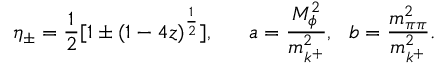Convert formula to latex. <formula><loc_0><loc_0><loc_500><loc_500>\eta _ { \pm } = { \frac { 1 } { 2 } } [ 1 \pm ( 1 - 4 z ) ^ { \frac { 1 } { 2 } } ] , a = { \frac { M _ { \phi } ^ { 2 } } { m _ { k ^ { + } } ^ { 2 } } } , b = { \frac { m _ { \pi \pi } ^ { 2 } } { m _ { k ^ { + } } ^ { 2 } } } .</formula> 